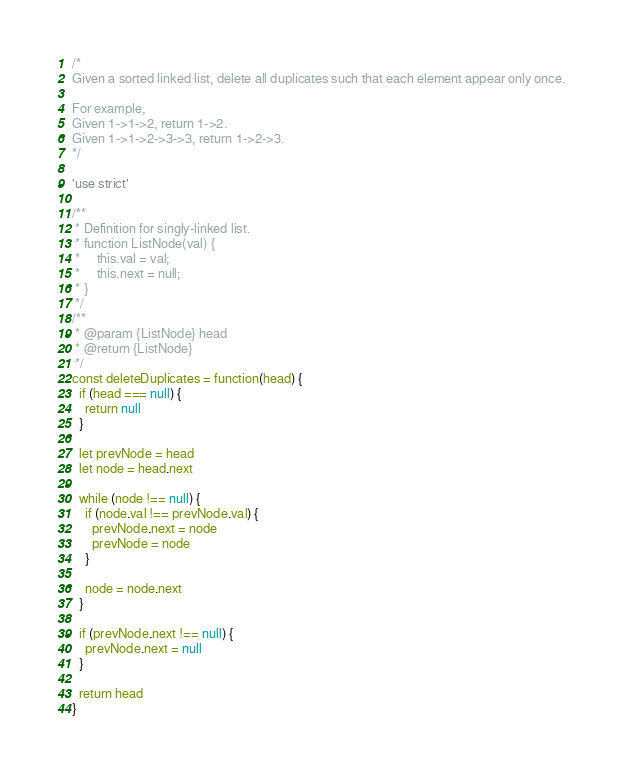<code> <loc_0><loc_0><loc_500><loc_500><_JavaScript_>/*
Given a sorted linked list, delete all duplicates such that each element appear only once.

For example,
Given 1->1->2, return 1->2.
Given 1->1->2->3->3, return 1->2->3.
*/

'use strict'

/**
 * Definition for singly-linked list.
 * function ListNode(val) {
 *     this.val = val;
 *     this.next = null;
 * }
 */
/**
 * @param {ListNode} head
 * @return {ListNode}
 */
const deleteDuplicates = function(head) {
  if (head === null) {
    return null
  }

  let prevNode = head
  let node = head.next

  while (node !== null) {
    if (node.val !== prevNode.val) {
      prevNode.next = node
      prevNode = node
    }

    node = node.next
  }

  if (prevNode.next !== null) {
    prevNode.next = null
  }

  return head
}
</code> 